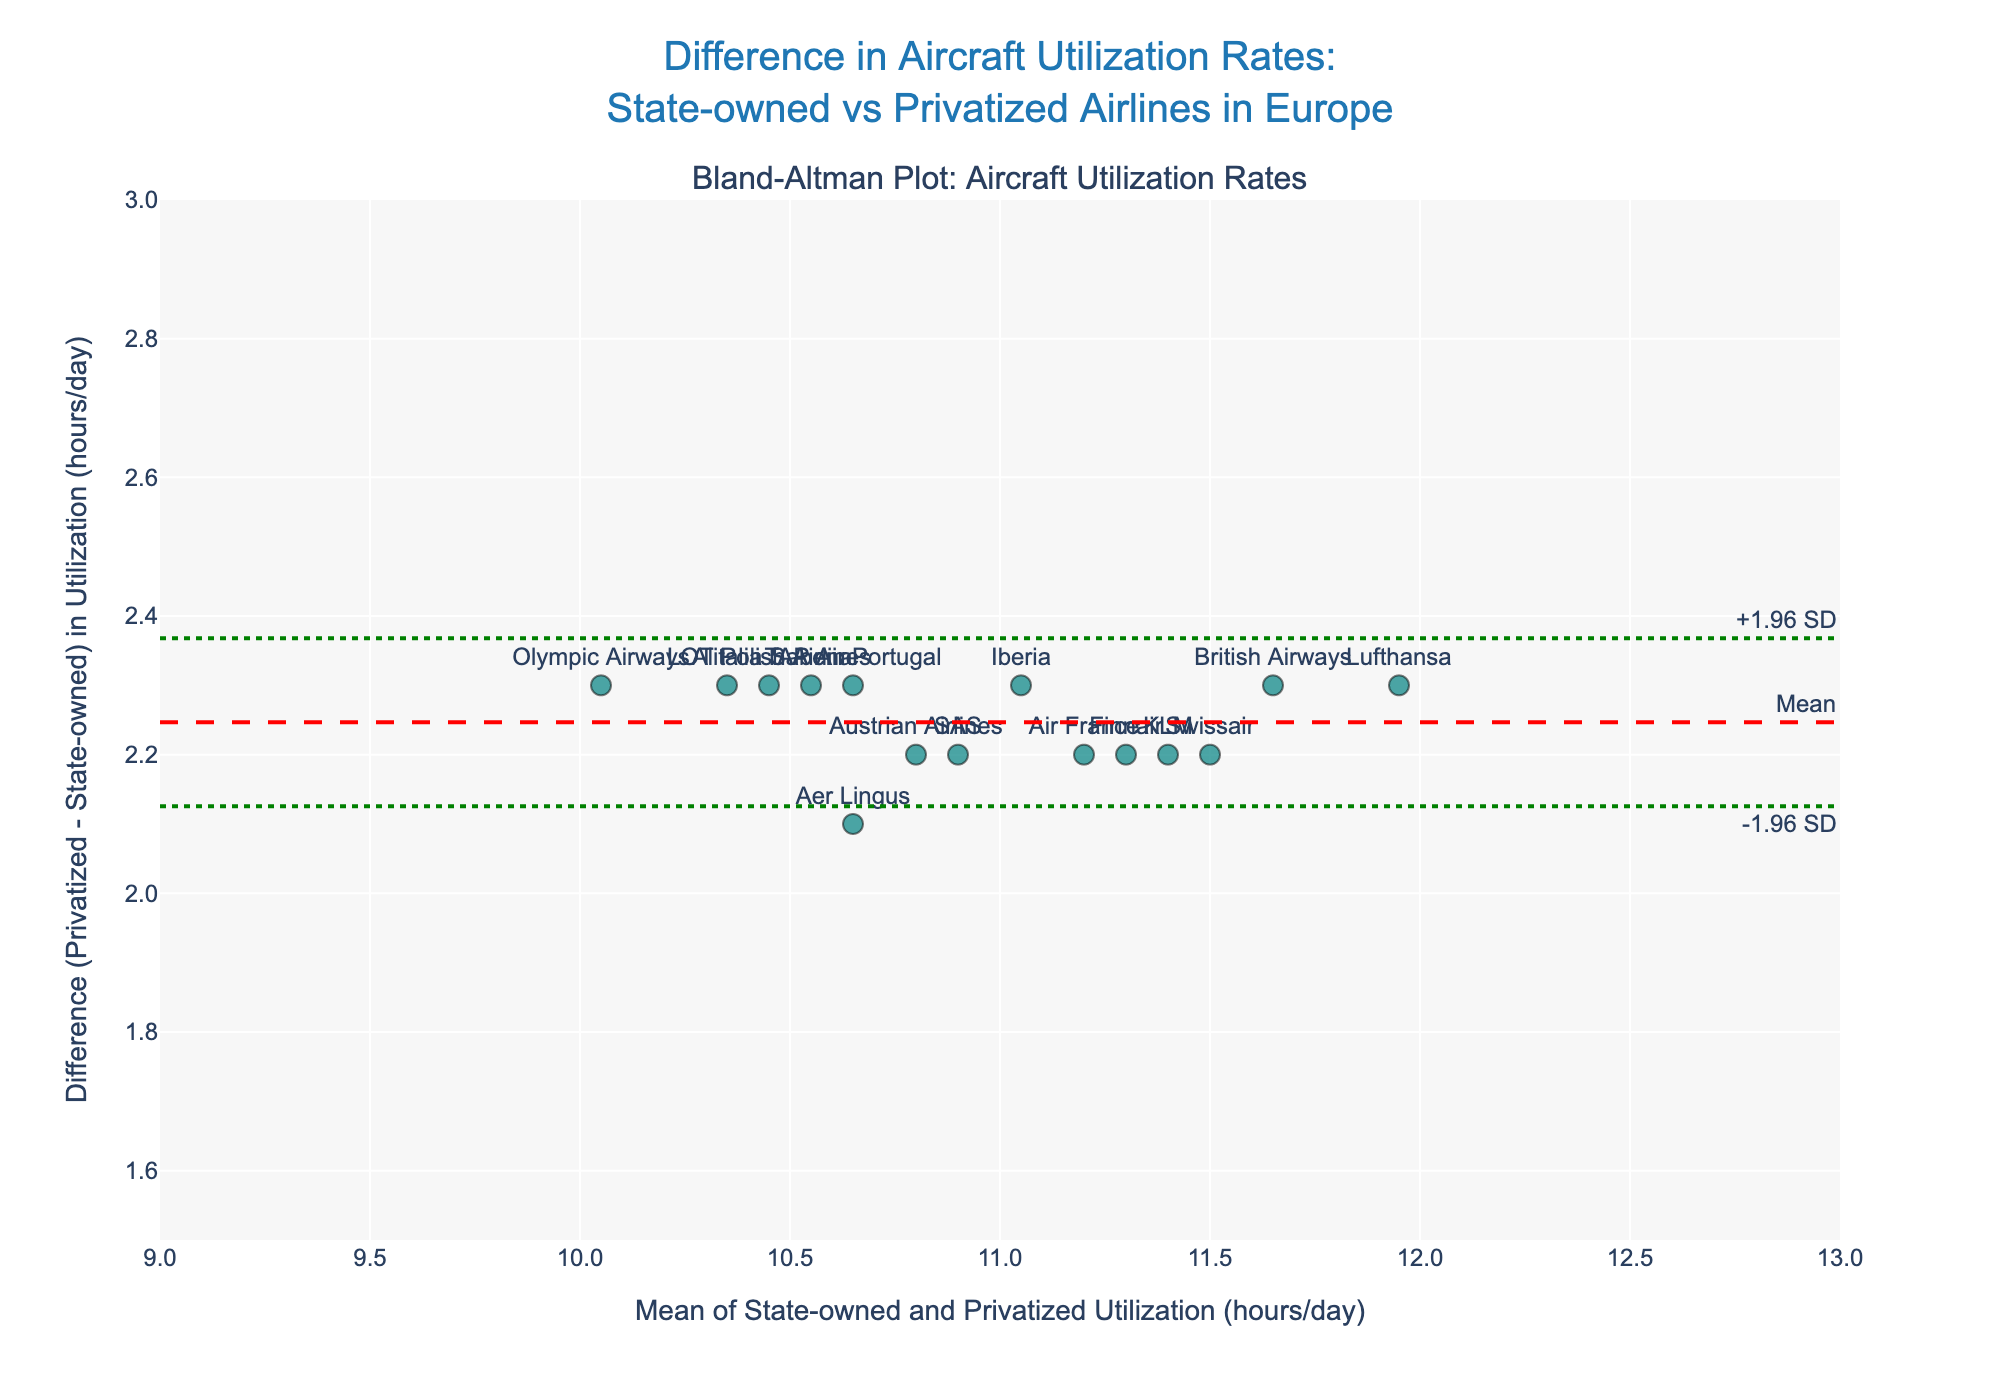what is the title of the plot? The title is located at the top center of the figure. It describes the overall content and purpose of the plot. It reads 'Difference in Aircraft Utilization Rates: State-owned vs Privatized Airlines in Europe'.
Answer: 'Difference in Aircraft Utilization Rates: State-owned vs Privatized Airlines in Europe' how many airlines are plotted in the figure? Each point on the Bland-Altman plot represents one airline. Counting the number of points on the plot gives the total number of airlines plotted, which is 15.
Answer: 15 what are the limits of agreement shown in the plot? The limits of agreement are depicted as dotted green lines on the plot. They represent the range within which 95% of the differences lie, calculated as mean difference ± 1.96 standard deviations. The lines are annotated with "-1.96 SD" and "+1.96 SD".
Answer: -1.96 SD and +1.96 SD what is the color of the points? The color of the points is consistent throughout the plot. They are teal with a translucent appearance, allowing easy distinction from the background.
Answer: teal which airline has the highest mean utilization rate? To determine this, find the data point on the x-axis that is farthest to the right since the x-axis shows the Mean of State-owned and Privatized Utilization Rates. The farthest point to the right contains the label 'Lufthansa', which indicates it has the highest mean utilization rate.
Answer: Lufthansa what is the average difference between state-owned and privatized utilization rates for these airlines? The mean difference is represented by the dashed red line annotated with 'Mean'. The y-value of this line is the mean difference. Based on the plot, the mean difference is approximately 2.3 hours/day.
Answer: 2.3 hours/day which airlines have a difference outside the limits of agreement? To find this, look for points that lie outside the dotted green lines representing the limits of agreement on the y-axis. According to the plot, all differences fall within the limits of agreement.
Answer: None which airline has the smallest utilization rate difference? The airline with the smallest difference is the one closest to the x-axis within the plot. Considering the points' vertical positions, 'Swissair' has the smallest difference as it lies closest to the x-axis.
Answer: Swissair does the plot suggest any systematic bias between state-owned and privatized airlines' utilization rates? The plot shows if the difference (privatized - state-owned) clusters around a value consistently. Here, the differences hover around a positive mean difference line, suggesting that privatized airlines generally have higher utilization rates, which indicates a systematic bias in favor of privatized airlines.
Answer: Yes, towards privatized airlines what is the main insight obtained from this Bland-Altman plot? The main insight from the plot is that privatized airlines in Europe tend to have higher aircraft utilization rates than state-owned airlines. This is illustrated by the positive mean difference and the clustering of data points above the zero line.
Answer: Privatized airlines have higher aircraft utilization rates 